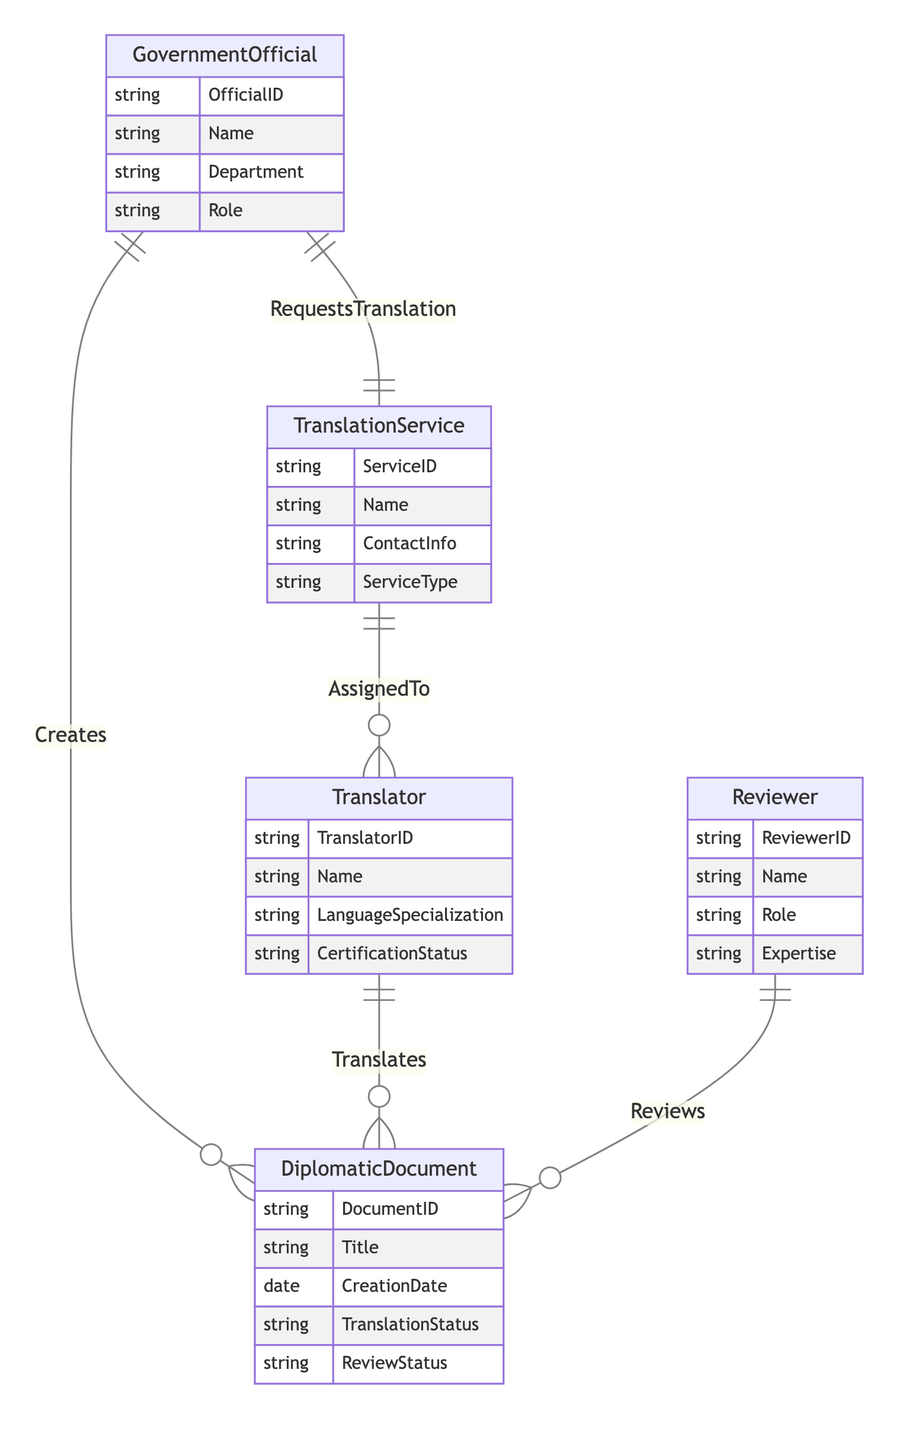What is the maximum number of Diplomatic Documents that can be created by a single Government Official? The relationship between Government Official and Diplomatic Document indicates a '1 to N' cardinality. This means one Government Official can create multiple Diplomatic Documents, implying there is no upper limit specified in the relationship.
Answer: N How many attributes does the Government Official entity have? The Government Official entity has four attributes listed: OfficialID, Name, Department, and Role. By counting these, we find the total.
Answer: 4 Which entity is responsible for translating a Diplomatic Document? The relationship labeled 'Translates' connects the Translator entity with the Diplomatic Document entity. Therefore, the Translator is responsible for this action according to the diagram.
Answer: Translator What is the relationship between the Government Official and the Translation Service? The relationship 'RequestsTranslation' links the Government Official to the Translation Service with a '1 to 1' cardinality, indicating each Government Official can request one Translation Service.
Answer: RequestsTranslation How many Translators can be assigned to a single Translation Service? According to the 'AssignedTo' relationship, there is a '1 to N' cardinality between Translation Service and Translator. This means a single Translation Service can be associated with multiple Translators.
Answer: N What role does a Reviewer play in relation to Diplomatic Documents? The 'Reviews' relationship connects the Reviewer entity to the Diplomatic Document entity. This indicates that the Reviewer is responsible for reviewing the Diplomatic Documents.
Answer: Reviews Is it possible for a Government Official to translate a Diplomatic Document? The diagram identifies specific roles for entities. The Government Official is connected to the Diplomatic Document through 'Creates', and the Translator translates the document. There is no direct link between Government Official and translation, making this impossible.
Answer: No What kind of specialization is required for Translators? The Translator entity includes the attribute 'LanguageSpecialization', which indicates that Translators must have a specialization in languages pertinent to their translations.
Answer: LanguageSpecialization Which entity manages the review process for Diplomatic Documents? The Reviewer entity is connected to Diplomatic Document through the relationship 'Reviews', which indicates that Reviewers manage and conduct the review process.
Answer: Reviewer 